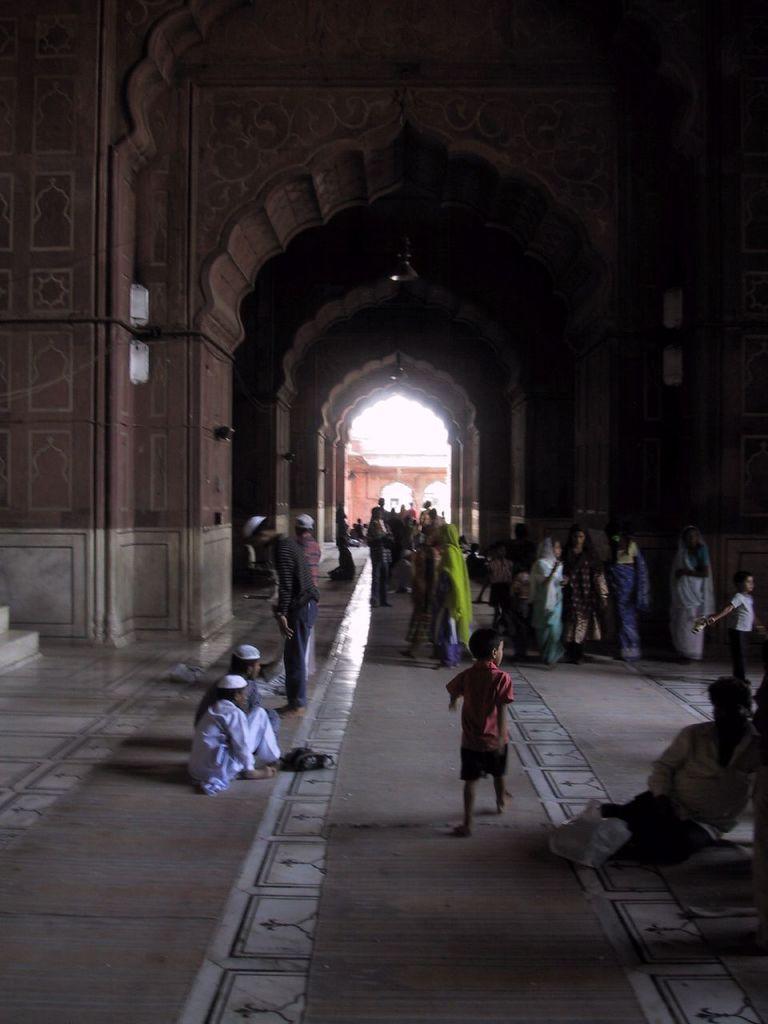Can you describe this image briefly? In this image we can see an interior of the mosque. There are many people in the image. 